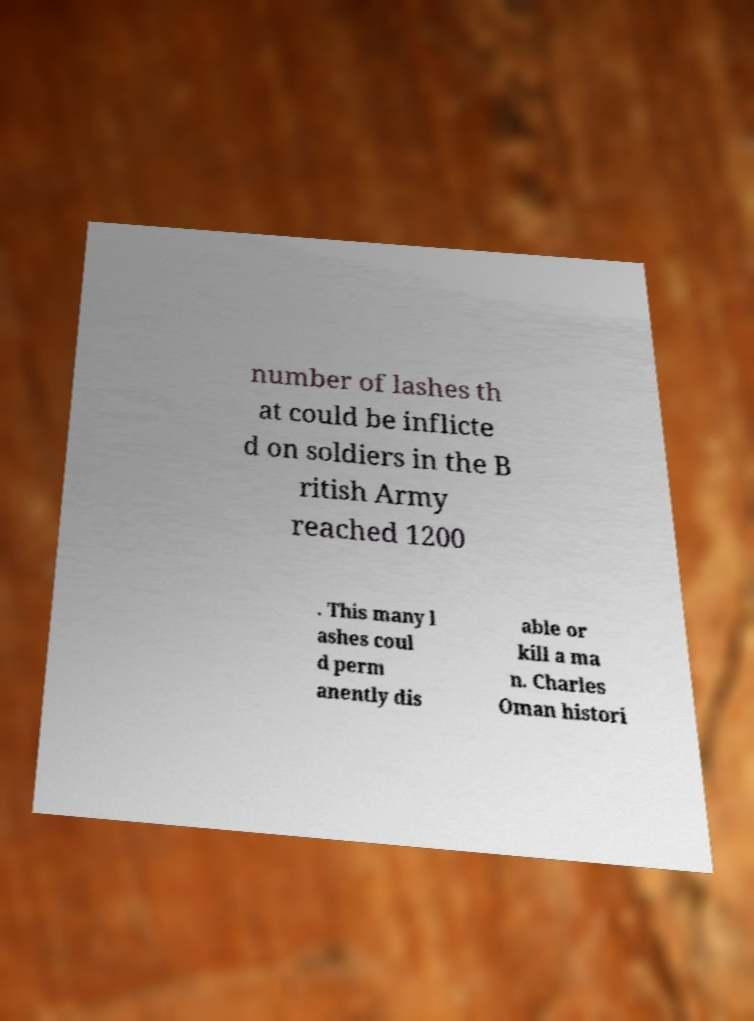Please read and relay the text visible in this image. What does it say? number of lashes th at could be inflicte d on soldiers in the B ritish Army reached 1200 . This many l ashes coul d perm anently dis able or kill a ma n. Charles Oman histori 